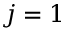Convert formula to latex. <formula><loc_0><loc_0><loc_500><loc_500>j = 1</formula> 